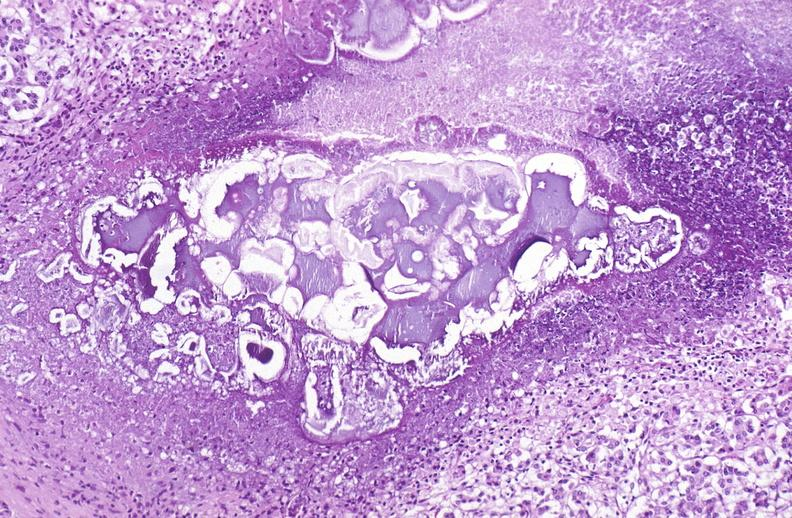does this image show pancreatic fat necrosis?
Answer the question using a single word or phrase. Yes 